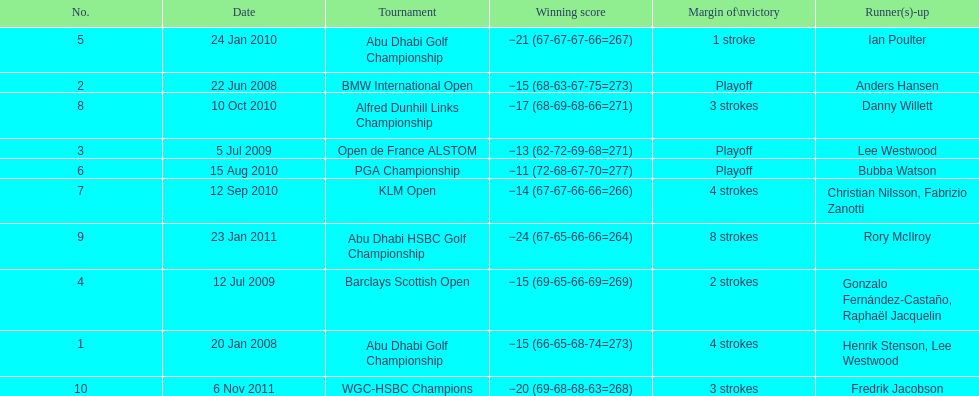Who had the top score in the pga championship? Bubba Watson. 